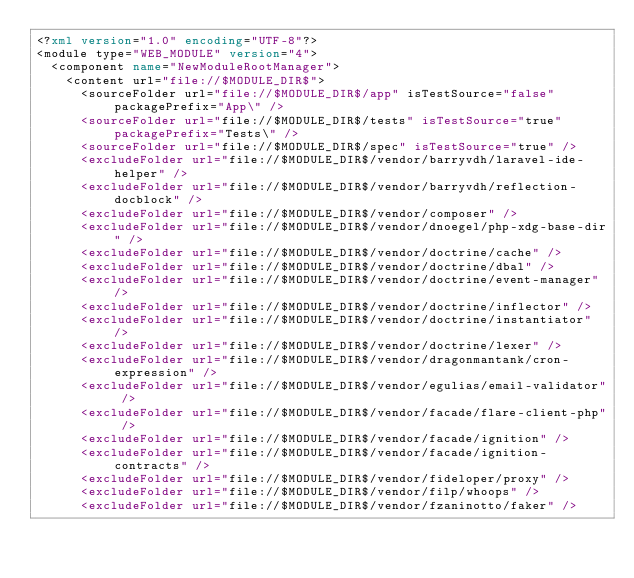<code> <loc_0><loc_0><loc_500><loc_500><_XML_><?xml version="1.0" encoding="UTF-8"?>
<module type="WEB_MODULE" version="4">
  <component name="NewModuleRootManager">
    <content url="file://$MODULE_DIR$">
      <sourceFolder url="file://$MODULE_DIR$/app" isTestSource="false" packagePrefix="App\" />
      <sourceFolder url="file://$MODULE_DIR$/tests" isTestSource="true" packagePrefix="Tests\" />
      <sourceFolder url="file://$MODULE_DIR$/spec" isTestSource="true" />
      <excludeFolder url="file://$MODULE_DIR$/vendor/barryvdh/laravel-ide-helper" />
      <excludeFolder url="file://$MODULE_DIR$/vendor/barryvdh/reflection-docblock" />
      <excludeFolder url="file://$MODULE_DIR$/vendor/composer" />
      <excludeFolder url="file://$MODULE_DIR$/vendor/dnoegel/php-xdg-base-dir" />
      <excludeFolder url="file://$MODULE_DIR$/vendor/doctrine/cache" />
      <excludeFolder url="file://$MODULE_DIR$/vendor/doctrine/dbal" />
      <excludeFolder url="file://$MODULE_DIR$/vendor/doctrine/event-manager" />
      <excludeFolder url="file://$MODULE_DIR$/vendor/doctrine/inflector" />
      <excludeFolder url="file://$MODULE_DIR$/vendor/doctrine/instantiator" />
      <excludeFolder url="file://$MODULE_DIR$/vendor/doctrine/lexer" />
      <excludeFolder url="file://$MODULE_DIR$/vendor/dragonmantank/cron-expression" />
      <excludeFolder url="file://$MODULE_DIR$/vendor/egulias/email-validator" />
      <excludeFolder url="file://$MODULE_DIR$/vendor/facade/flare-client-php" />
      <excludeFolder url="file://$MODULE_DIR$/vendor/facade/ignition" />
      <excludeFolder url="file://$MODULE_DIR$/vendor/facade/ignition-contracts" />
      <excludeFolder url="file://$MODULE_DIR$/vendor/fideloper/proxy" />
      <excludeFolder url="file://$MODULE_DIR$/vendor/filp/whoops" />
      <excludeFolder url="file://$MODULE_DIR$/vendor/fzaninotto/faker" /></code> 